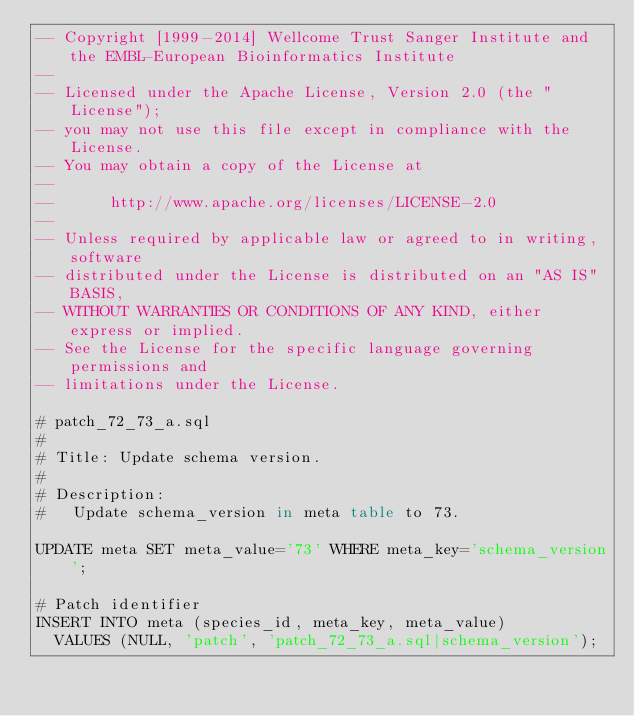Convert code to text. <code><loc_0><loc_0><loc_500><loc_500><_SQL_>-- Copyright [1999-2014] Wellcome Trust Sanger Institute and the EMBL-European Bioinformatics Institute
-- 
-- Licensed under the Apache License, Version 2.0 (the "License");
-- you may not use this file except in compliance with the License.
-- You may obtain a copy of the License at
-- 
--      http://www.apache.org/licenses/LICENSE-2.0
-- 
-- Unless required by applicable law or agreed to in writing, software
-- distributed under the License is distributed on an "AS IS" BASIS,
-- WITHOUT WARRANTIES OR CONDITIONS OF ANY KIND, either express or implied.
-- See the License for the specific language governing permissions and
-- limitations under the License.

# patch_72_73_a.sql
#
# Title: Update schema version.
#
# Description:
#   Update schema_version in meta table to 73.

UPDATE meta SET meta_value='73' WHERE meta_key='schema_version';

# Patch identifier
INSERT INTO meta (species_id, meta_key, meta_value)
  VALUES (NULL, 'patch', 'patch_72_73_a.sql|schema_version');
</code> 